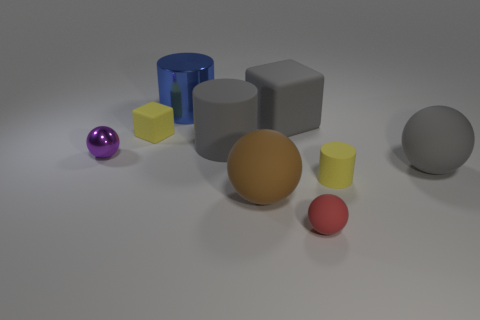Add 1 big yellow matte spheres. How many objects exist? 10 Subtract all cubes. How many objects are left? 7 Add 2 small shiny balls. How many small shiny balls are left? 3 Add 5 small metal objects. How many small metal objects exist? 6 Subtract 1 gray cylinders. How many objects are left? 8 Subtract all tiny green cylinders. Subtract all gray objects. How many objects are left? 6 